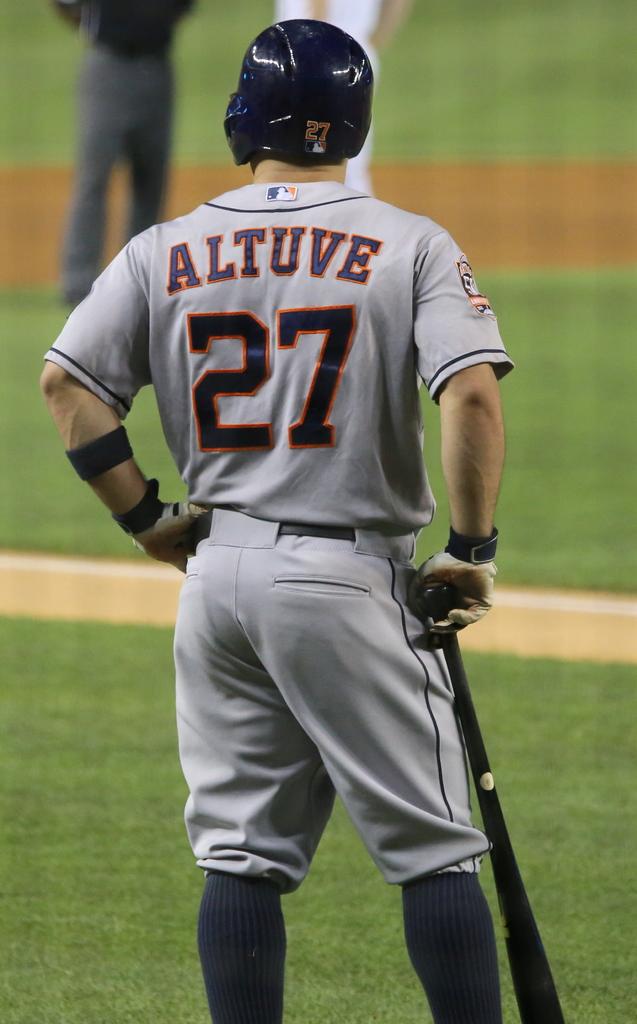What is the players number written on his jersey?
Keep it short and to the point. 27. 